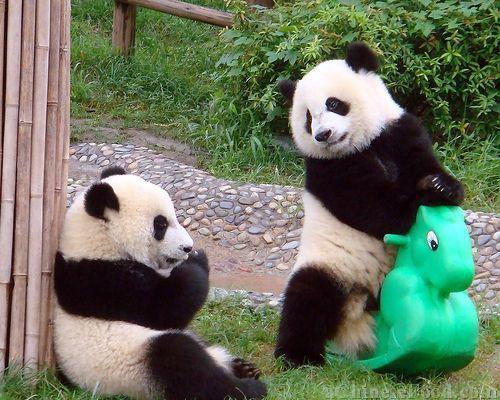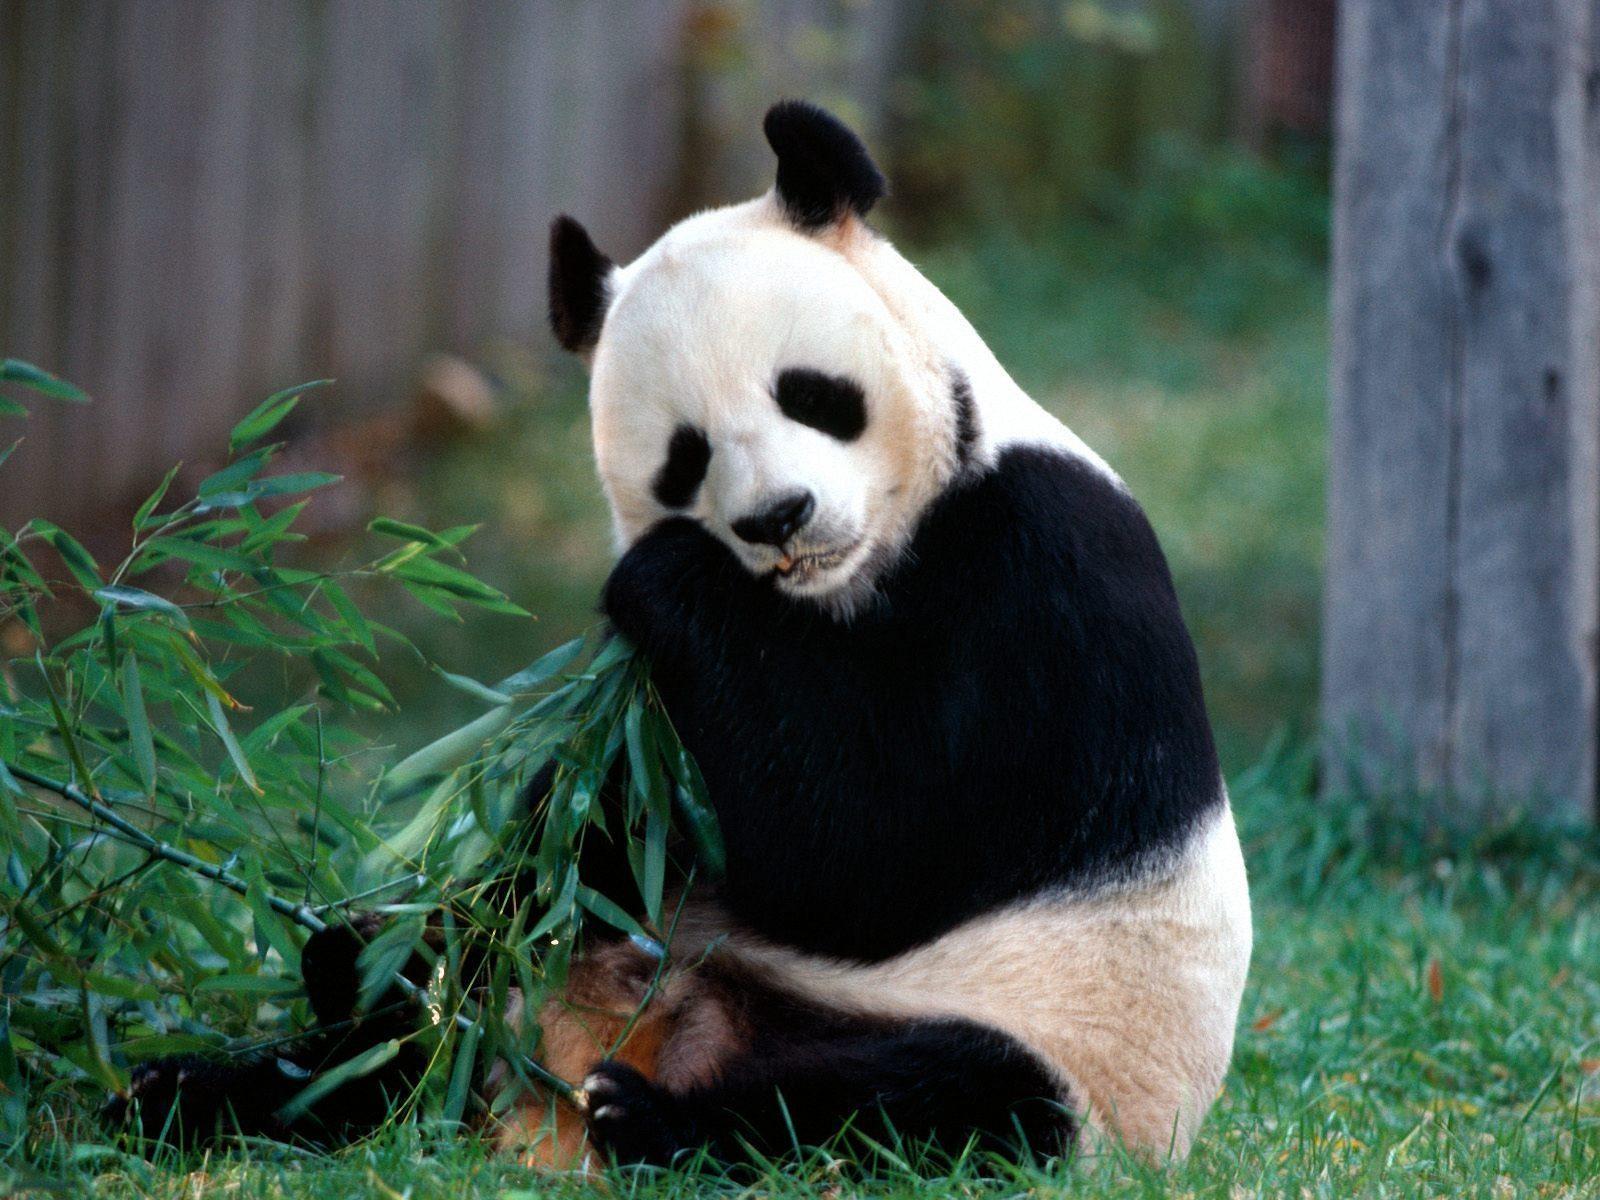The first image is the image on the left, the second image is the image on the right. For the images displayed, is the sentence "In one image, a standing panda figure on the right is looking down toward another panda, and in the other image, the mouth of a panda with its body turned leftward and its face forward is next to leafy foliage." factually correct? Answer yes or no. Yes. The first image is the image on the left, the second image is the image on the right. Analyze the images presented: Is the assertion "There are two different animal species in the right image." valid? Answer yes or no. No. 